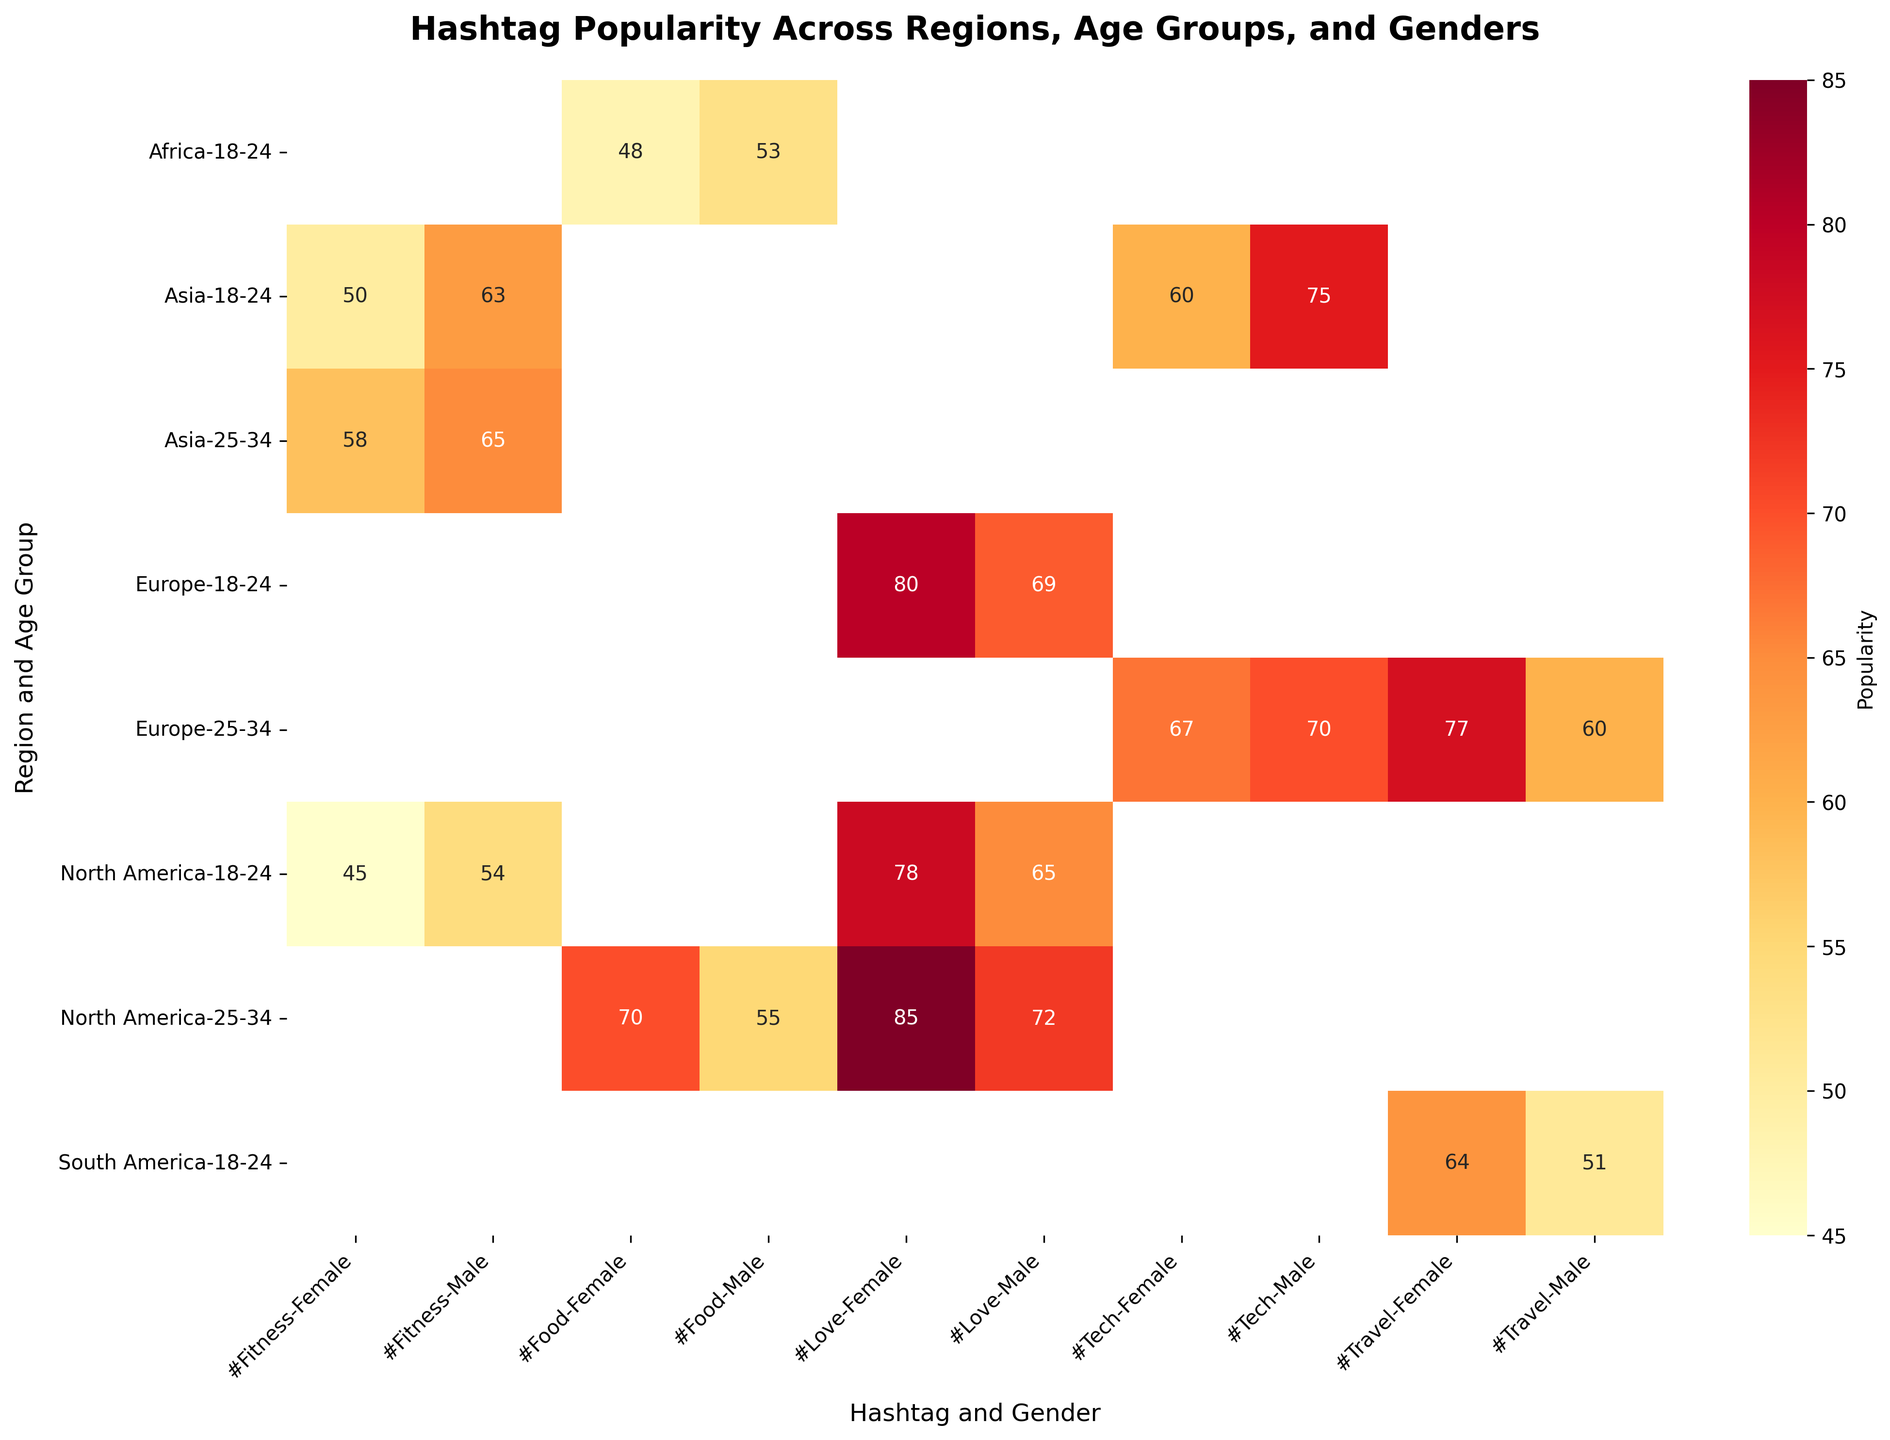How is the popularity of the hashtag '#Love' different between males and females in North America for the age group 25-34? First, locate the cells for the hashtag '#Love' in the 'North America' region for the age group '25-34' for both 'Male' and 'Female.' The popularity values are 72 (Male) and 85 (Female). Comparing these values, the popularity is higher for females.
Answer: Females have a higher popularity with a value of 85 What is the average popularity of the hashtag '#Fitness' in Asia for both age groups and genders? Check the popularity values for the hashtag '#Fitness' in the 'Asia' region for both age groups and both genders. The values are 50 (Female, 18-24), 63 (Male, 18-24), 58 (Female, 25-34), and 65 (Male, 25-34). Sum these values: 50 + 63 + 58 + 65 = 236. Now divide by the number of values, which is 4. The average popularity is 236 / 4 = 59.
Answer: 59 Which region has the highest popularity for the hashtag '#Travel' for females aged 25-34? Locate the hashtag '#Travel' in the different regions for females aged 25-34. The values are 77 (Europe) and there are no other values for females aged 25-34. Hence, the highest popularity for this group is in Europe.
Answer: Europe with a value of 77 What is the difference in the popularity of '#Food' between females and males in North America for the age group 25-34? Identify the popularity values for the hashtag '#Food' in the 'North America' region for the age group '25-34' for both 'Male' and 'Female.' The popularity values are 70 (Female) and 55 (Male). The difference is calculated as 70 - 55 = 15.
Answer: 15 In which region is the hashtag '#Tech' more popular among 18-24 males? Check the popularity values for the hashtag '#Tech' in each region for 18-24 males. The values are 75 (Asia) and there are no other regions for 18-24 males. Hence, the popularity for this group is highest in Asia.
Answer: Asia with a value of 75 Which hashtag has the highest overall popularity among 25-34 females in North America? Look at the popularity values for hashtags among 25-34 females in North America. The values are 85 (#Love) and 70 (#Food). The highest value is 85 for the hashtag '#Love.'
Answer: #Love with a value of 85 Is 'Fitness' more popular among males or females aged 18-24 in North America? Locate the popularity values for the hashtag '#Fitness' for males and females aged 18-24 in North America. The values are 54 (Males) and 45 (Females). Comparing these values, '#Fitness' is more popular among males.
Answer: Males with a value of 54 What is the combined popularity of the hashtags '#Love' and '#Food' in North America for the demographic of males aged 25-34? Find the popularity values for the hashtags '#Love' and '#Food' in North America for males aged 25-34. The values are 72 (#Love) and 55 (#Food). Adding these values together: 72 + 55 = 127.
Answer: 127 Which age group in Europe has a higher popularity for the hashtag '#Tech,' 25-34 males or females? Check the popularity values for the hashtag '#Tech' in Europe for the age group 25-34 for both males and females. The values are 70 (Male) and 67 (Female). Comparing these values, '#Tech' has a higher popularity among males.
Answer: Males with a value of 70 